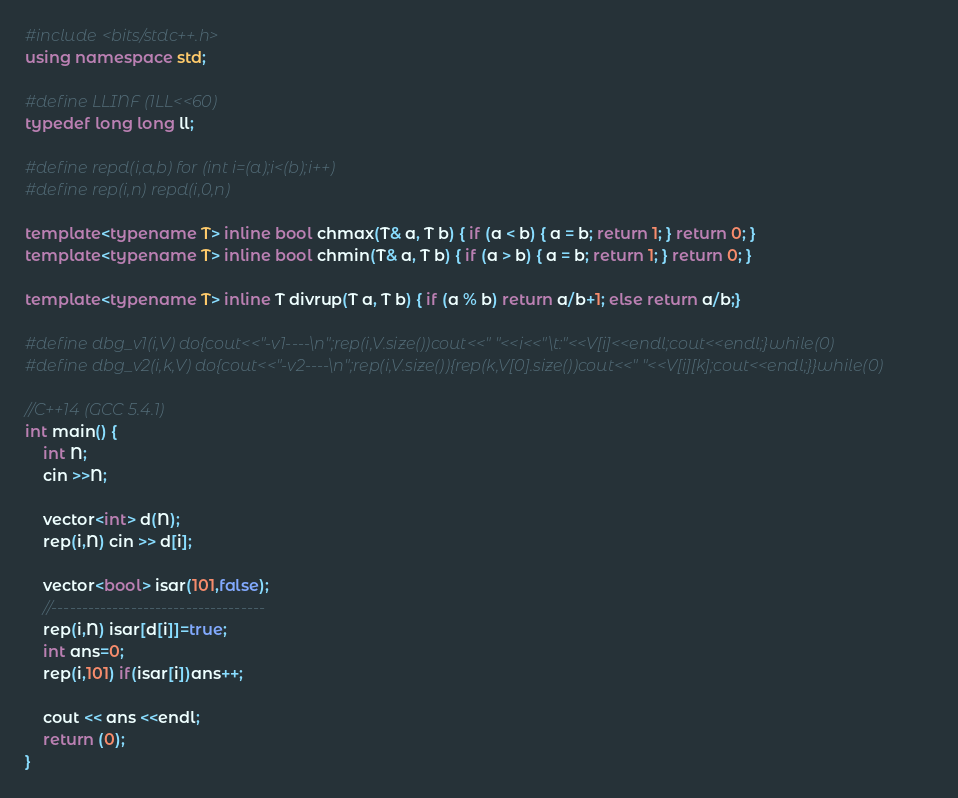Convert code to text. <code><loc_0><loc_0><loc_500><loc_500><_C++_>#include <bits/stdc++.h>
using namespace std;

#define LLINF (1LL<<60)
typedef long long ll;

#define repd(i,a,b) for (int i=(a);i<(b);i++)
#define rep(i,n) repd(i,0,n)

template<typename T> inline bool chmax(T& a, T b) { if (a < b) { a = b; return 1; } return 0; }
template<typename T> inline bool chmin(T& a, T b) { if (a > b) { a = b; return 1; } return 0; }

template<typename T> inline T divrup(T a, T b) { if (a % b) return a/b+1; else return a/b;}

#define dbg_v1(i,V) do{cout<<"-v1----\n";rep(i,V.size())cout<<" "<<i<<"\t:"<<V[i]<<endl;cout<<endl;}while(0)
#define dbg_v2(i,k,V) do{cout<<"-v2----\n";rep(i,V.size()){rep(k,V[0].size())cout<<" "<<V[i][k];cout<<endl;}}while(0)

//C++14 (GCC 5.4.1)
int main() {
    int N;
    cin >>N;

    vector<int> d(N);
    rep(i,N) cin >> d[i];
    
    vector<bool> isar(101,false);
    //-----------------------------------
    rep(i,N) isar[d[i]]=true;
    int ans=0;
    rep(i,101) if(isar[i])ans++;

    cout << ans <<endl;
    return (0);
}</code> 